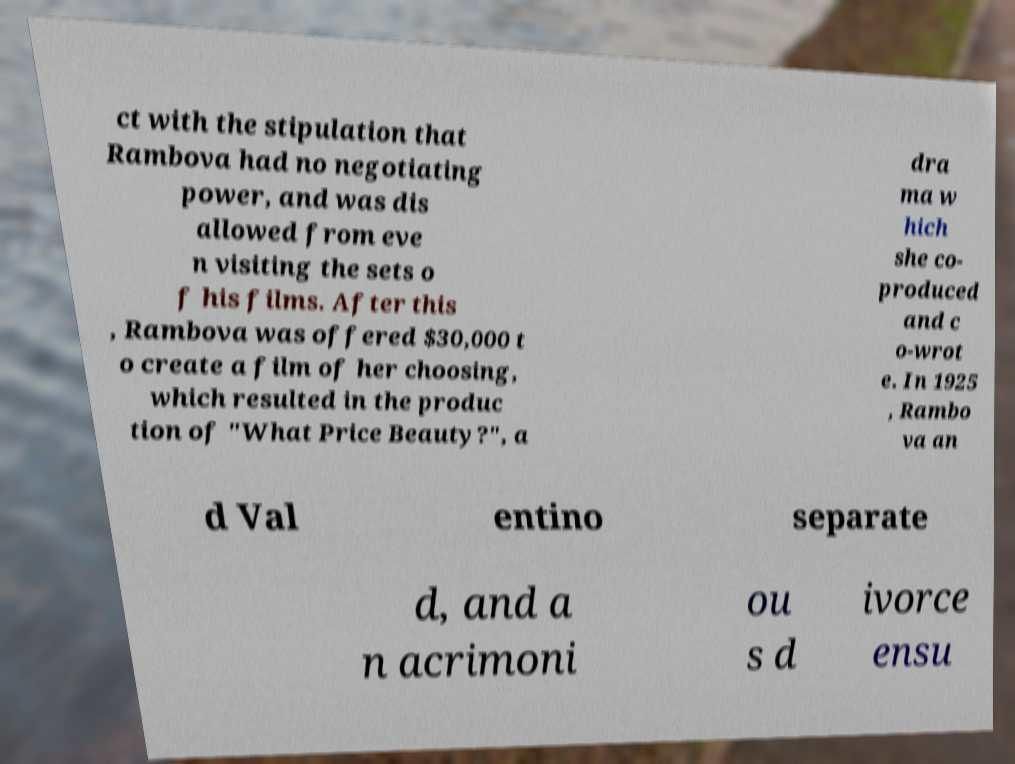Can you accurately transcribe the text from the provided image for me? ct with the stipulation that Rambova had no negotiating power, and was dis allowed from eve n visiting the sets o f his films. After this , Rambova was offered $30,000 t o create a film of her choosing, which resulted in the produc tion of "What Price Beauty?", a dra ma w hich she co- produced and c o-wrot e. In 1925 , Rambo va an d Val entino separate d, and a n acrimoni ou s d ivorce ensu 